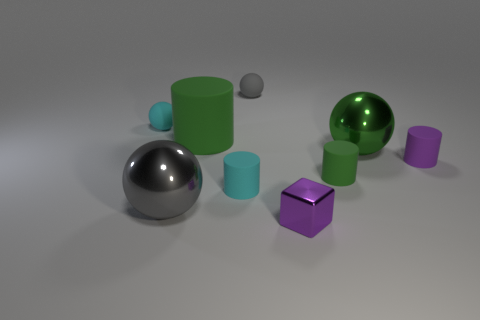Are the shiny objects reflective, and if so, what can they reflect from their current position? The shiny objects appear to have a reflective surface. They could potentially reflect the other objects around them and any light source present, giving a glimpse of the environment within their shiny surfaces. 